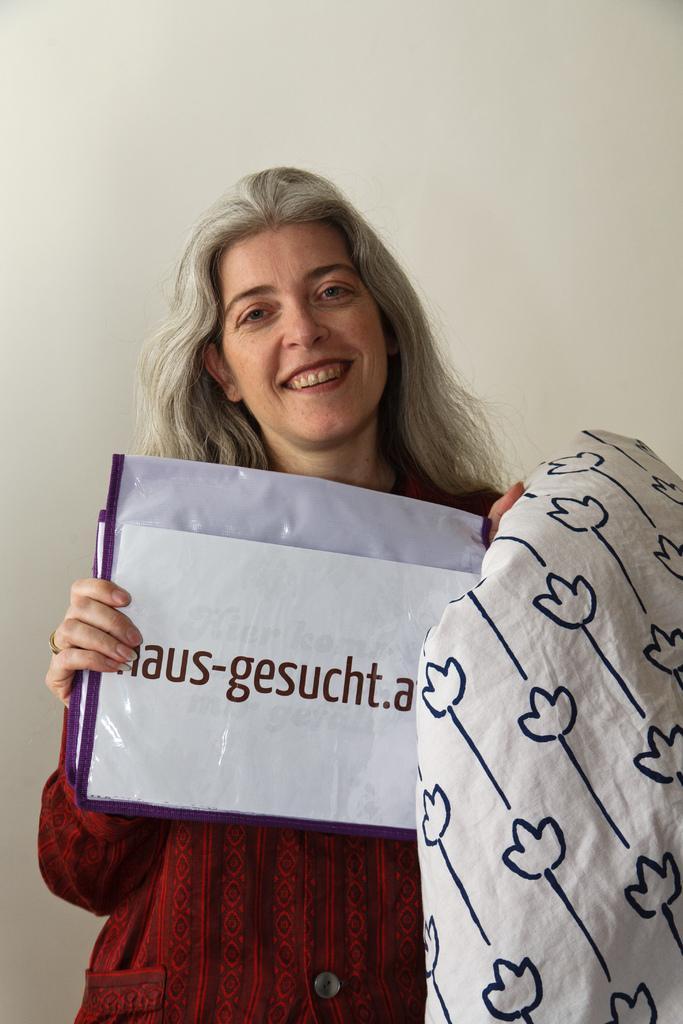Could you give a brief overview of what you see in this image? In this image we can see a lady holding a paper with something written. Also there is a cloth. In the background there is a wall. 